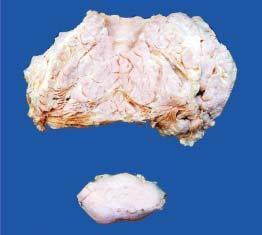does hurthle show a separate encapsulated gelatinous mass?
Answer the question using a single word or phrase. No 